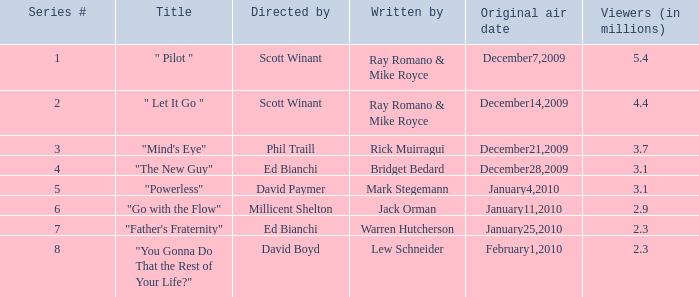What is the episode number of  "you gonna do that the rest of your life?" 8.0. 